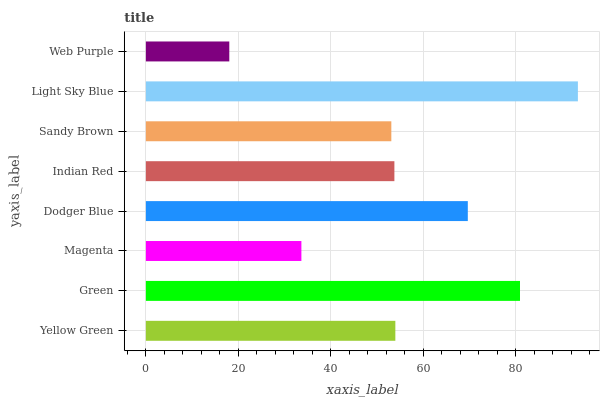Is Web Purple the minimum?
Answer yes or no. Yes. Is Light Sky Blue the maximum?
Answer yes or no. Yes. Is Green the minimum?
Answer yes or no. No. Is Green the maximum?
Answer yes or no. No. Is Green greater than Yellow Green?
Answer yes or no. Yes. Is Yellow Green less than Green?
Answer yes or no. Yes. Is Yellow Green greater than Green?
Answer yes or no. No. Is Green less than Yellow Green?
Answer yes or no. No. Is Yellow Green the high median?
Answer yes or no. Yes. Is Indian Red the low median?
Answer yes or no. Yes. Is Dodger Blue the high median?
Answer yes or no. No. Is Dodger Blue the low median?
Answer yes or no. No. 